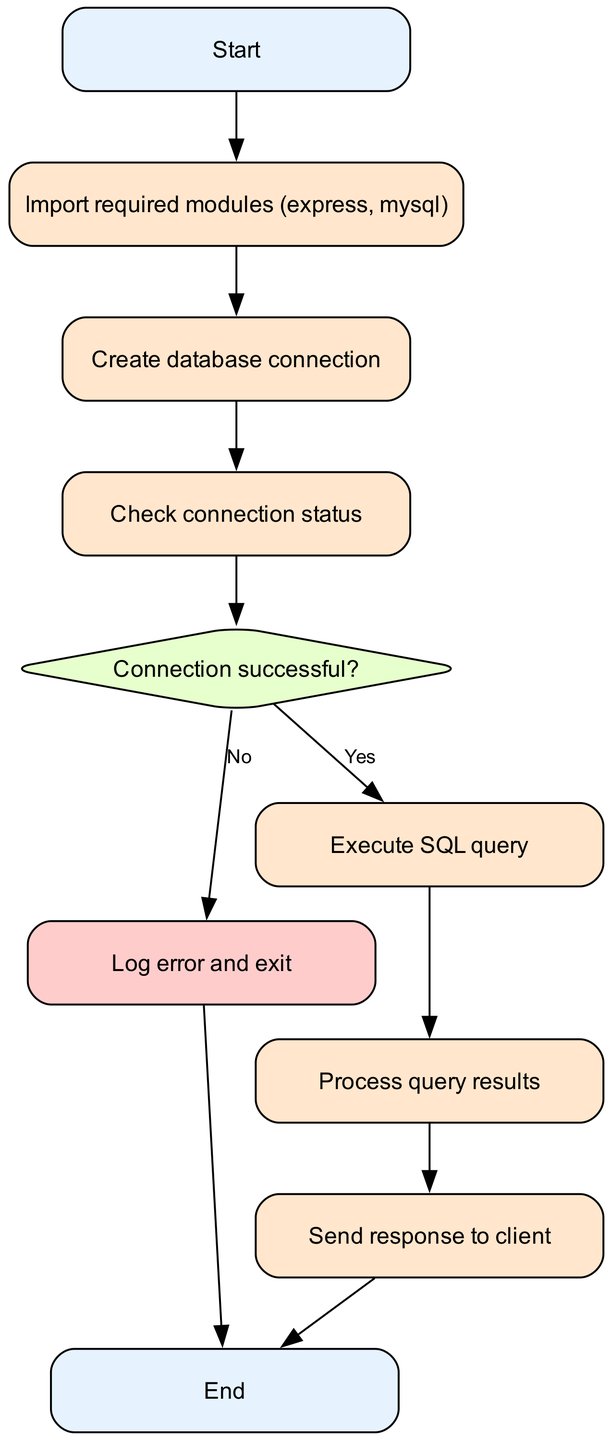What is the first step in the diagram? The first step in the diagram is the "Start" node, which represents the initiation of the database connection process.
Answer: Start How many nodes are there in the diagram? To determine the total number of nodes, we count each unique node listed: Start, Import, Connect, Check, Decision, Error, Query, Results, Response, and End, yielding a total of 10 nodes.
Answer: 10 What happens if the connection to the database is not successful? If the connection is not successful, the process will directly lead to the "Log error and exit" node, indicated by the "No" decision path from the "Connection successful?" node.
Answer: Log error and exit What is the purpose of the “Send response to client” node? The purpose of the "Send response to client" node is to convey the results of the executed SQL query back to the client, occurring after the results are processed.
Answer: Send response to client After executing the SQL query, which node comes next? After the "Execute SQL query" node, the next node is "Process query results," which processes the results returned by the SQL execution.
Answer: Process query results What color represents decision nodes in the diagram? The color representing decision nodes in the diagram is a light green shade, specified in the diagram as "#E6FFCC."
Answer: Light green What is the final node in the flow chart? The final node in the flow chart is the "End" node, indicating the conclusion of the database connection and query execution process.
Answer: End If the database connection is successful, what is the next action? If the database connection is successful, the next action is to "Execute SQL query," which follows the "Connection successful?" decision path.
Answer: Execute SQL query Identify the nodes that represent processes in the diagram. The nodes that represent processes in the diagram are "Import required modules," "Create database connection," "Execute SQL query," and "Process query results."
Answer: Import required modules, Create database connection, Execute SQL query, Process query results 